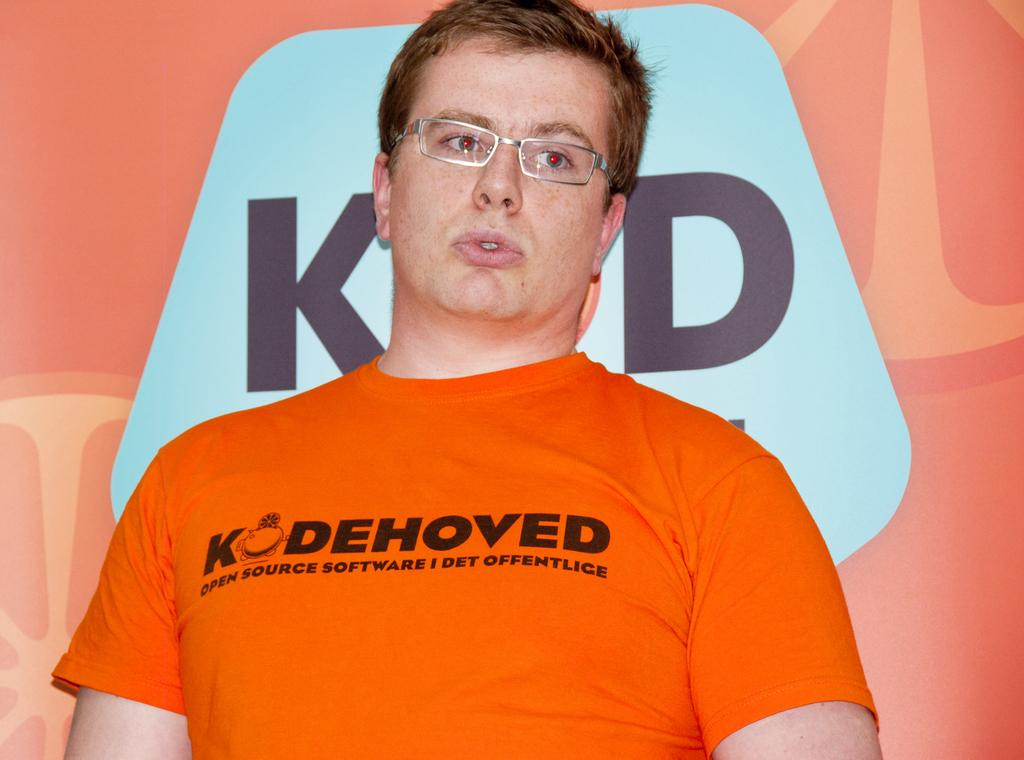Who is present in the image? There is a man in the image. What accessory is the man wearing? The man is wearing spectacles. What can be seen in the background of the image? There is a poster in the background of the image. What is written or depicted on the poster? The poster has some text on it. How many trees can be seen in the image? There are no trees visible in the image. What type of monkey is sitting on the man's shoulder in the image? There is no monkey present in the image. 